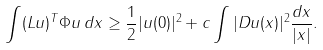Convert formula to latex. <formula><loc_0><loc_0><loc_500><loc_500>\int ( L u ) ^ { T } \Phi u \, d x \geq \frac { 1 } { 2 } | u ( 0 ) | ^ { 2 } + c \int | D u ( x ) | ^ { 2 } \frac { d x } { | x | } .</formula> 